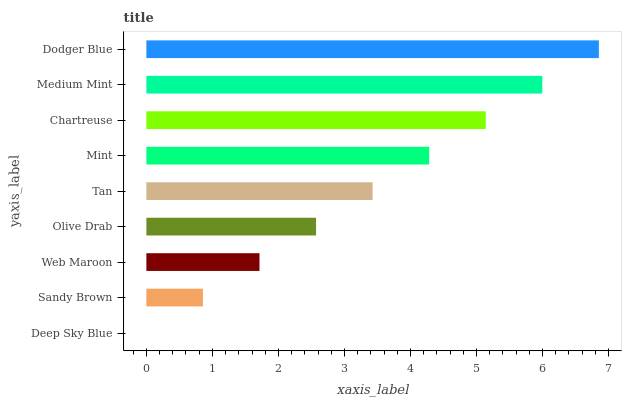Is Deep Sky Blue the minimum?
Answer yes or no. Yes. Is Dodger Blue the maximum?
Answer yes or no. Yes. Is Sandy Brown the minimum?
Answer yes or no. No. Is Sandy Brown the maximum?
Answer yes or no. No. Is Sandy Brown greater than Deep Sky Blue?
Answer yes or no. Yes. Is Deep Sky Blue less than Sandy Brown?
Answer yes or no. Yes. Is Deep Sky Blue greater than Sandy Brown?
Answer yes or no. No. Is Sandy Brown less than Deep Sky Blue?
Answer yes or no. No. Is Tan the high median?
Answer yes or no. Yes. Is Tan the low median?
Answer yes or no. Yes. Is Dodger Blue the high median?
Answer yes or no. No. Is Medium Mint the low median?
Answer yes or no. No. 